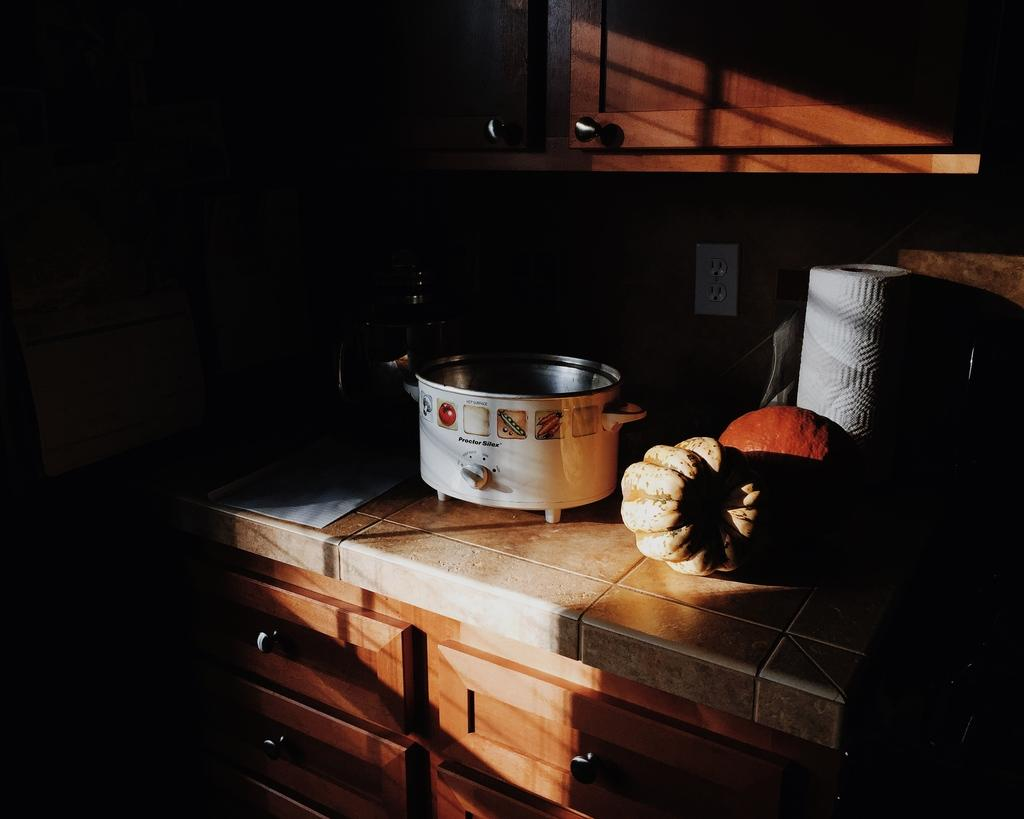What type of furniture is present in the image? There are cupboards in the image. What is the main feature of the platform in the image? A tissue paper roll and an electric cooker are present on the platform. What else can be seen on the platform? There are other things visible on the platform. Where is the socket located in the image? There is a socket on the wall. How does the mint smell in the image? There is no mint present in the image, so it cannot be smelled or described. 